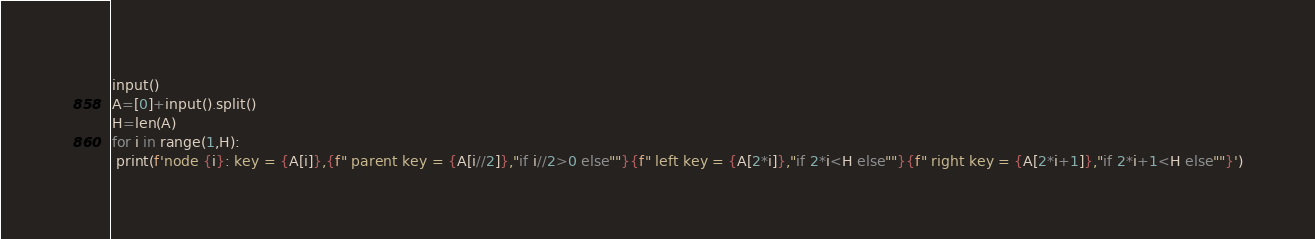Convert code to text. <code><loc_0><loc_0><loc_500><loc_500><_Python_>input()
A=[0]+input().split()
H=len(A)
for i in range(1,H):
 print(f'node {i}: key = {A[i]},{f" parent key = {A[i//2]},"if i//2>0 else""}{f" left key = {A[2*i]},"if 2*i<H else""}{f" right key = {A[2*i+1]},"if 2*i+1<H else""}')
</code> 